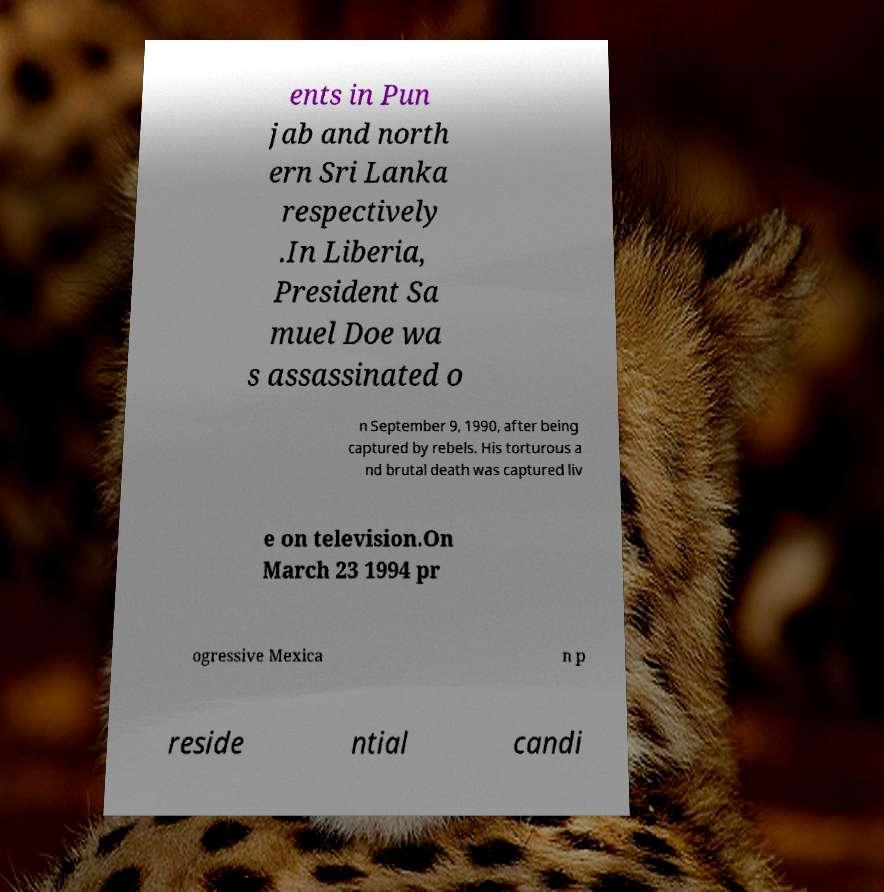Please identify and transcribe the text found in this image. ents in Pun jab and north ern Sri Lanka respectively .In Liberia, President Sa muel Doe wa s assassinated o n September 9, 1990, after being captured by rebels. His torturous a nd brutal death was captured liv e on television.On March 23 1994 pr ogressive Mexica n p reside ntial candi 